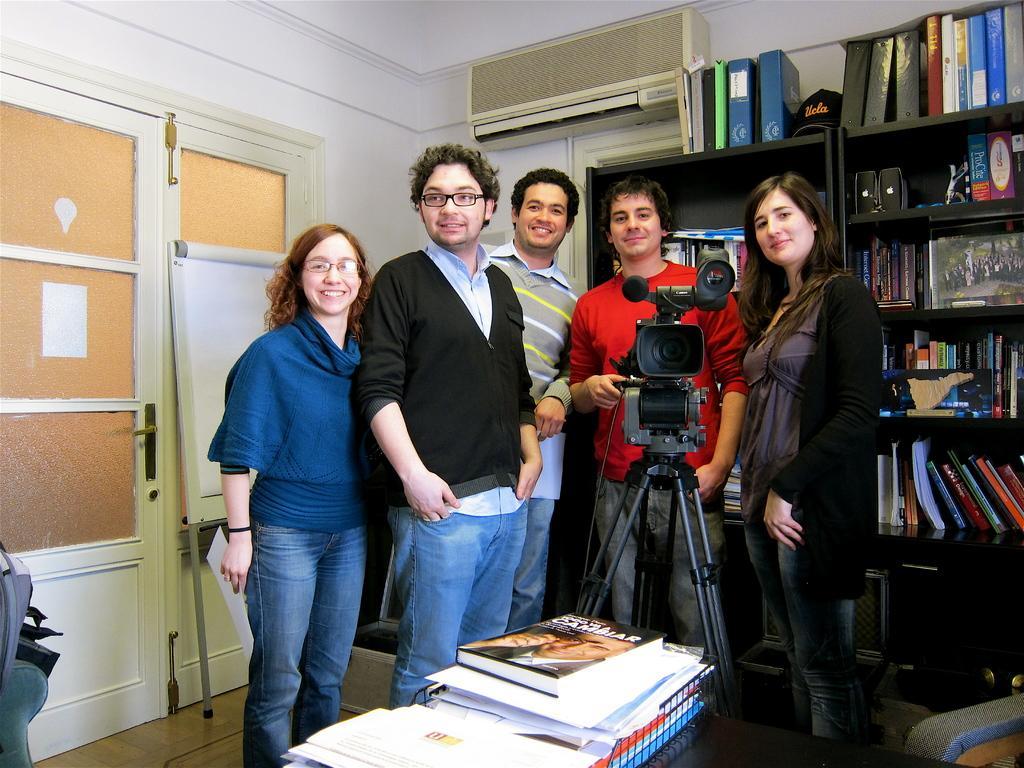Can you describe this image briefly? In this picture we can see there are five people standing on the floor and in front of the people there is a camera with the stand and some books. On the left side of the people there is a door and a white board. Behind the people there is an "AC" on the wall, some books and speakers in the racks. 